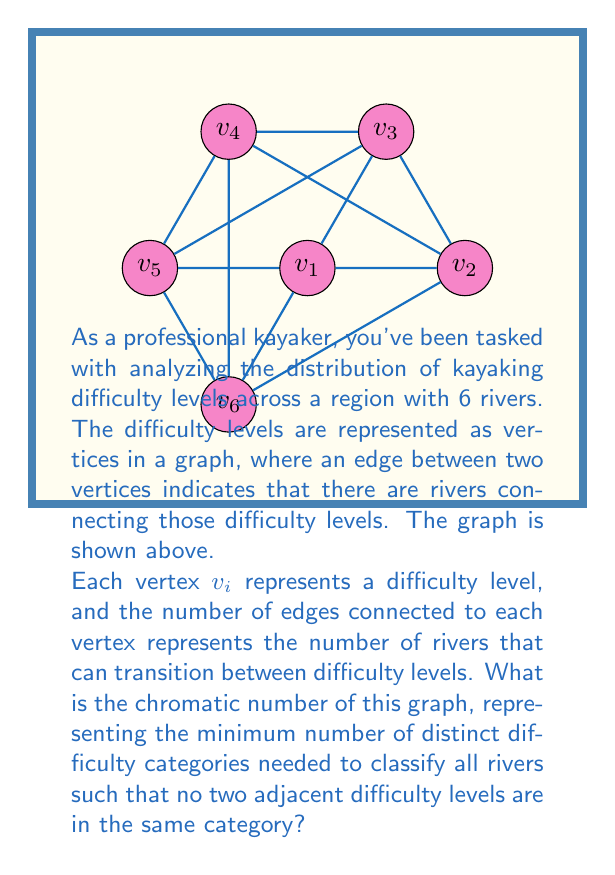Teach me how to tackle this problem. To find the chromatic number of this graph, we'll follow these steps:

1) First, observe that this graph is regular, with each vertex having degree 4.

2) The graph has 6 vertices and forms a complete bipartite graph $K_{3,3}$ with an additional cycle around the perimeter.

3) In a bipartite graph, we need at least 2 colors. Let's try to color the graph with 2 colors:

   - Color $v_1$, $v_3$, and $v_5$ with color 1
   - Color $v_2$, $v_4$, and $v_6$ with color 2

4) This coloring works for the bipartite structure, but fails for the outer cycle. For example, $v_1$ and $v_6$ are adjacent but have the same color.

5) Let's try 3 colors:

   - Color $v_1$ and $v_4$ with color 1
   - Color $v_2$ and $v_5$ with color 2
   - Color $v_3$ and $v_6$ with color 3

6) This coloring satisfies all adjacency conditions:
   - No two adjacent vertices on the outer cycle have the same color
   - No two vertices connected across the graph have the same color

7) Therefore, the chromatic number is 3. We've found a valid 3-coloring, and we know we need at least 3 colors due to the odd cycle in the graph.

The chromatic number of 3 means that we need at least 3 distinct difficulty categories to classify all rivers in this region, ensuring that no two adjacent difficulty levels are in the same category.
Answer: 3 